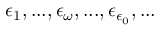<formula> <loc_0><loc_0><loc_500><loc_500>\epsilon _ { 1 } , \dots , \epsilon _ { \omega } , \dots , \epsilon _ { \epsilon _ { 0 } } , \dots</formula> 